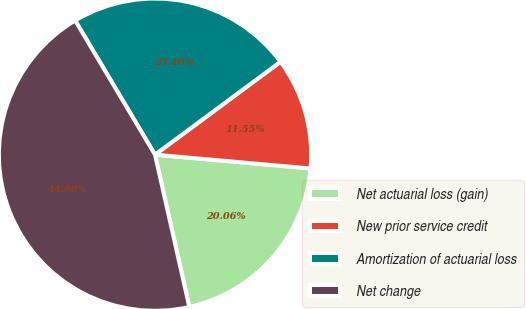<chart> <loc_0><loc_0><loc_500><loc_500><pie_chart><fcel>Net actuarial loss (gain)<fcel>New prior service credit<fcel>Amortization of actuarial loss<fcel>Net change<nl><fcel>20.06%<fcel>11.55%<fcel>23.4%<fcel>44.98%<nl></chart> 